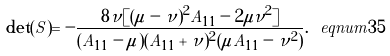Convert formula to latex. <formula><loc_0><loc_0><loc_500><loc_500>\det ( S ) = - \frac { 8 \nu [ ( \mu - \nu ) ^ { 2 } A _ { 1 1 } - 2 \mu \nu ^ { 2 } ] } { ( A _ { 1 1 } - \mu ) ( A _ { 1 1 } + \nu ) ^ { 2 } ( \mu A _ { 1 1 } - \nu ^ { 2 } ) } . \ e q n u m { 3 5 }</formula> 